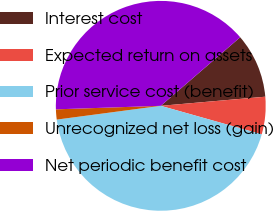<chart> <loc_0><loc_0><loc_500><loc_500><pie_chart><fcel>Interest cost<fcel>Expected return on assets<fcel>Prior service cost (benefit)<fcel>Unrecognized net loss (gain)<fcel>Net periodic benefit cost<nl><fcel>9.95%<fcel>5.76%<fcel>43.53%<fcel>1.56%<fcel>39.2%<nl></chart> 